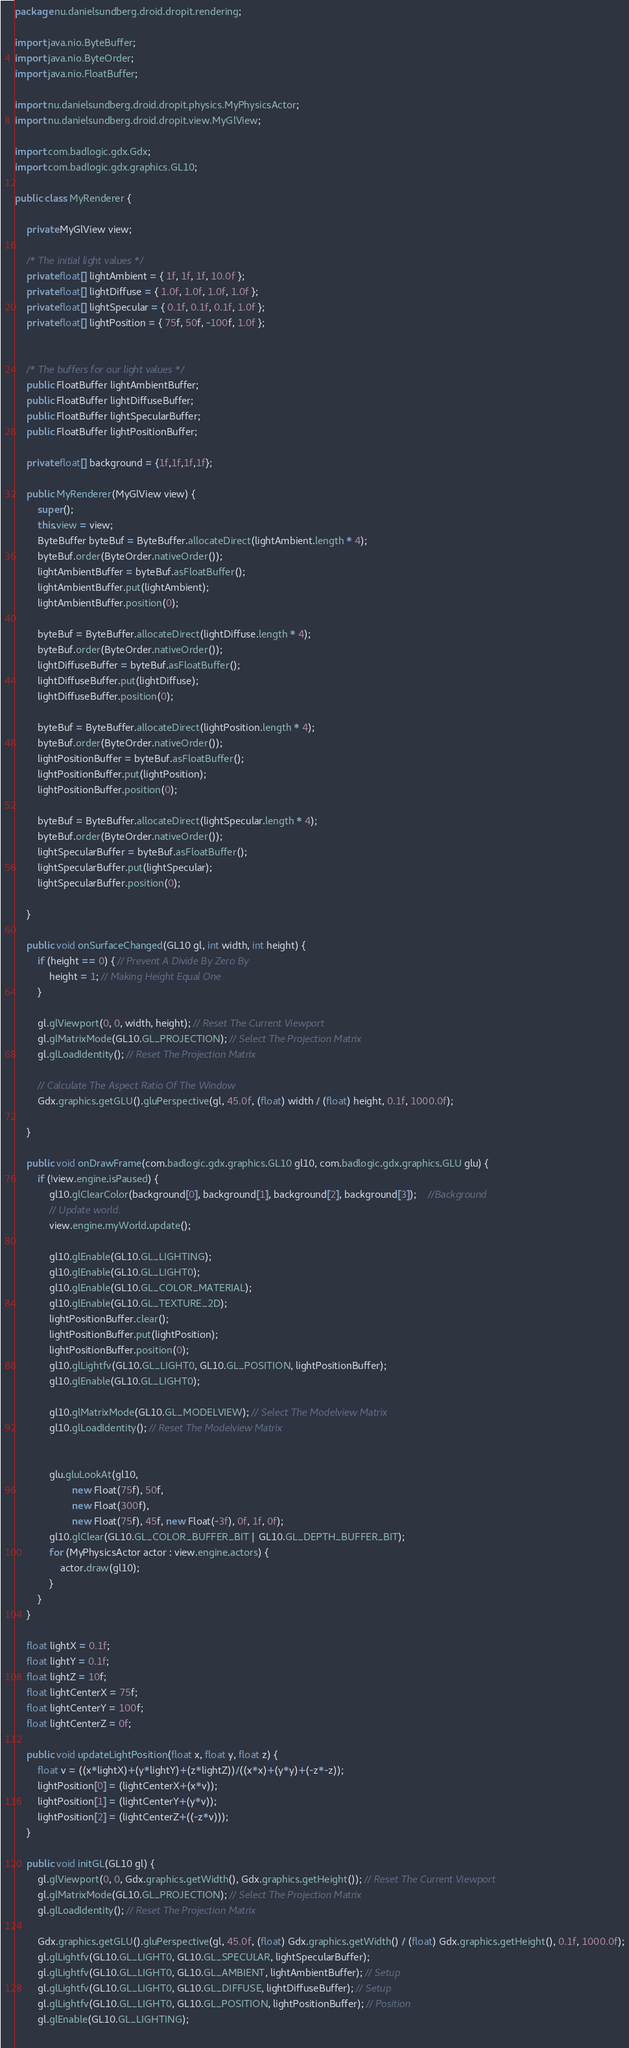<code> <loc_0><loc_0><loc_500><loc_500><_Java_>package nu.danielsundberg.droid.dropit.rendering;

import java.nio.ByteBuffer;
import java.nio.ByteOrder;
import java.nio.FloatBuffer;

import nu.danielsundberg.droid.dropit.physics.MyPhysicsActor;
import nu.danielsundberg.droid.dropit.view.MyGlView;

import com.badlogic.gdx.Gdx;
import com.badlogic.gdx.graphics.GL10;

public class MyRenderer {
	
	private MyGlView view;

	/* The initial light values */
	private float[] lightAmbient = { 1f, 1f, 1f, 10.0f };
	private float[] lightDiffuse = { 1.0f, 1.0f, 1.0f, 1.0f };
	private float[] lightSpecular = { 0.1f, 0.1f, 0.1f, 1.0f };
	private float[] lightPosition = { 75f, 50f, -100f, 1.0f };
	

	/* The buffers for our light values */
	public FloatBuffer lightAmbientBuffer;
	public FloatBuffer lightDiffuseBuffer;
	public FloatBuffer lightSpecularBuffer;
	public FloatBuffer lightPositionBuffer;
	
	private float[] background = {1f,1f,1f,1f};

	public MyRenderer(MyGlView view) {
		super();
		this.view = view;
		ByteBuffer byteBuf = ByteBuffer.allocateDirect(lightAmbient.length * 4);
		byteBuf.order(ByteOrder.nativeOrder());
		lightAmbientBuffer = byteBuf.asFloatBuffer();
		lightAmbientBuffer.put(lightAmbient);
		lightAmbientBuffer.position(0);

		byteBuf = ByteBuffer.allocateDirect(lightDiffuse.length * 4);
		byteBuf.order(ByteOrder.nativeOrder());
		lightDiffuseBuffer = byteBuf.asFloatBuffer();
		lightDiffuseBuffer.put(lightDiffuse);
		lightDiffuseBuffer.position(0);
		
		byteBuf = ByteBuffer.allocateDirect(lightPosition.length * 4);
		byteBuf.order(ByteOrder.nativeOrder());
		lightPositionBuffer = byteBuf.asFloatBuffer();
		lightPositionBuffer.put(lightPosition);
		lightPositionBuffer.position(0);

		byteBuf = ByteBuffer.allocateDirect(lightSpecular.length * 4);
		byteBuf.order(ByteOrder.nativeOrder());
		lightSpecularBuffer = byteBuf.asFloatBuffer();
		lightSpecularBuffer.put(lightSpecular);
		lightSpecularBuffer.position(0);

	}	

	public void onSurfaceChanged(GL10 gl, int width, int height) {
		if (height == 0) { // Prevent A Divide By Zero By
			height = 1; // Making Height Equal One
		}

		gl.glViewport(0, 0, width, height); // Reset The Current Viewport
		gl.glMatrixMode(GL10.GL_PROJECTION); // Select The Projection Matrix
		gl.glLoadIdentity(); // Reset The Projection Matrix

		// Calculate The Aspect Ratio Of The Window
		Gdx.graphics.getGLU().gluPerspective(gl, 45.0f, (float) width / (float) height, 0.1f, 1000.0f);

	}

	public void onDrawFrame(com.badlogic.gdx.graphics.GL10 gl10, com.badlogic.gdx.graphics.GLU glu) {
		if (!view.engine.isPaused) {
			gl10.glClearColor(background[0], background[1], background[2], background[3]); 	//Background
			// Update world.
			view.engine.myWorld.update();
			
			gl10.glEnable(GL10.GL_LIGHTING);
            gl10.glEnable(GL10.GL_LIGHT0);
            gl10.glEnable(GL10.GL_COLOR_MATERIAL);
            gl10.glEnable(GL10.GL_TEXTURE_2D);
			lightPositionBuffer.clear();
			lightPositionBuffer.put(lightPosition);
			lightPositionBuffer.position(0);
			gl10.glLightfv(GL10.GL_LIGHT0, GL10.GL_POSITION, lightPositionBuffer);
			gl10.glEnable(GL10.GL_LIGHT0);
			
			gl10.glMatrixMode(GL10.GL_MODELVIEW); // Select The Modelview Matrix
			gl10.glLoadIdentity(); // Reset The Modelview Matrix
		
			
			glu.gluLookAt(gl10,
					new Float(75f), 50f,
					new Float(300f),
					new Float(75f), 45f, new Float(-3f), 0f, 1f, 0f);
			gl10.glClear(GL10.GL_COLOR_BUFFER_BIT | GL10.GL_DEPTH_BUFFER_BIT);
			for (MyPhysicsActor actor : view.engine.actors) {
				actor.draw(gl10);
			} 
		}
	}

	float lightX = 0.1f;
	float lightY = 0.1f;
	float lightZ = 10f;
	float lightCenterX = 75f;
	float lightCenterY = 100f;
	float lightCenterZ = 0f;
	
	public void updateLightPosition(float x, float y, float z) {
		float v = ((x*lightX)+(y*lightY)+(z*lightZ))/((x*x)+(y*y)+(-z*-z)); 
		lightPosition[0] = (lightCenterX+(x*v));
		lightPosition[1] = (lightCenterY+(y*v));
		lightPosition[2] = (lightCenterZ+((-z*v)));
	}

	public void initGL(GL10 gl) {
		gl.glViewport(0, 0, Gdx.graphics.getWidth(), Gdx.graphics.getHeight()); // Reset The Current Viewport
		gl.glMatrixMode(GL10.GL_PROJECTION); // Select The Projection Matrix
		gl.glLoadIdentity(); // Reset The Projection Matrix

		Gdx.graphics.getGLU().gluPerspective(gl, 45.0f, (float) Gdx.graphics.getWidth() / (float) Gdx.graphics.getHeight(), 0.1f, 1000.0f);
		gl.glLightfv(GL10.GL_LIGHT0, GL10.GL_SPECULAR, lightSpecularBuffer);
		gl.glLightfv(GL10.GL_LIGHT0, GL10.GL_AMBIENT, lightAmbientBuffer); // Setup
		gl.glLightfv(GL10.GL_LIGHT0, GL10.GL_DIFFUSE, lightDiffuseBuffer); // Setup
		gl.glLightfv(GL10.GL_LIGHT0, GL10.GL_POSITION, lightPositionBuffer); // Position
		gl.glEnable(GL10.GL_LIGHTING);
		</code> 